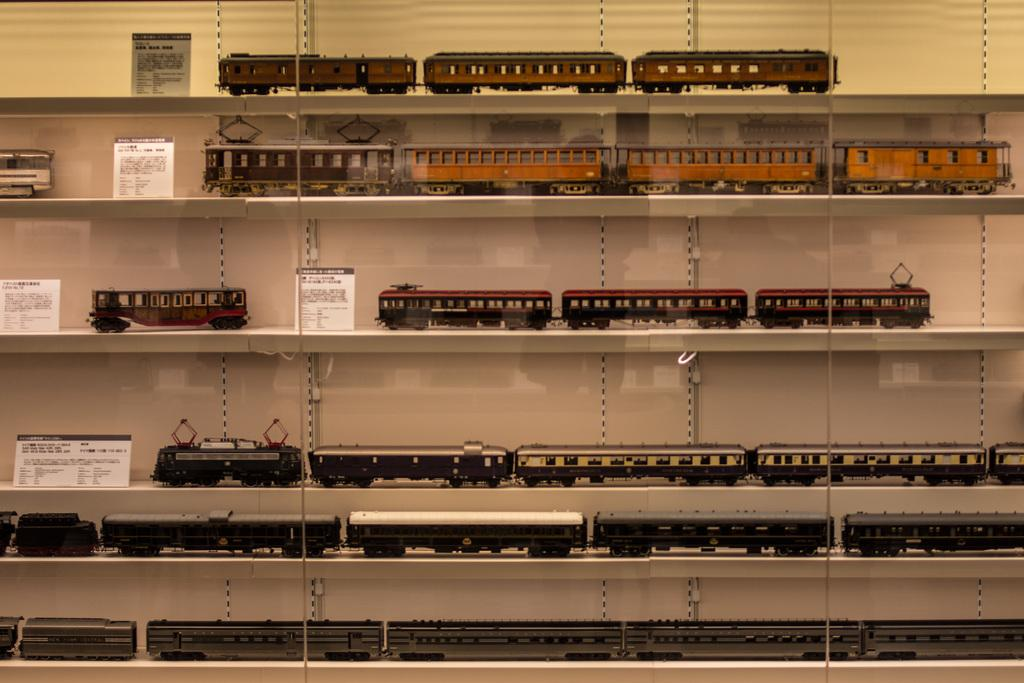What is the main object in the image? There is a rack in the image. What types of vehicles are depicted on the rack? The rack has depictions of trains and buses. Are there any other objects visible in the image? Yes, there are text boards in the image. Can you see a hose being used by a boy to crack open a cracker in the image? No, there is no hose, boy, or cracker present in the image. 